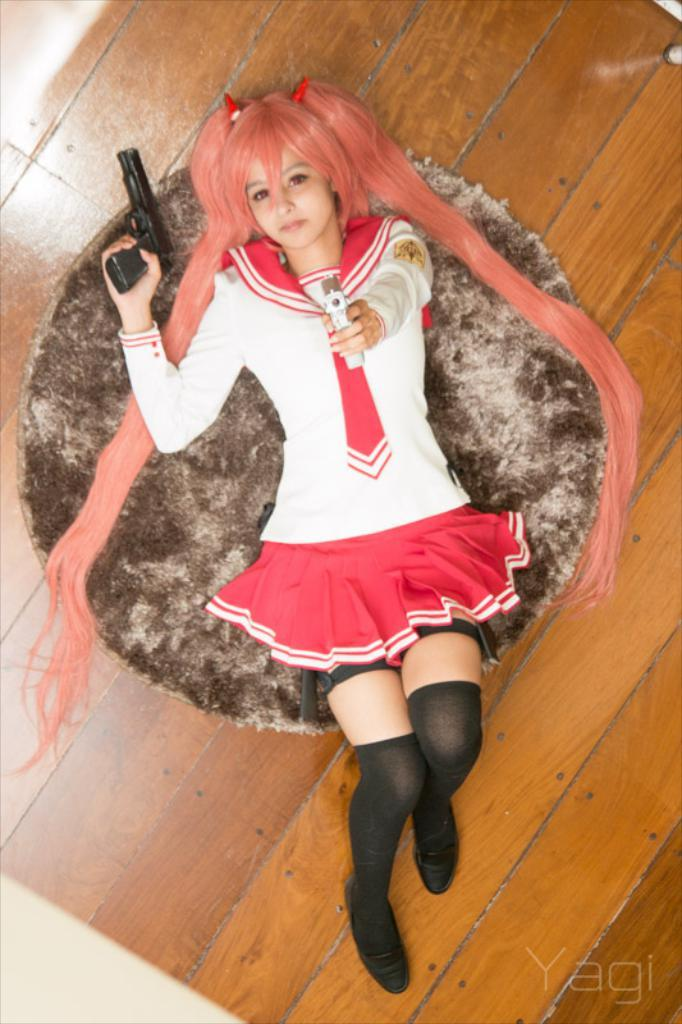What is the main subject of the image? There is a person in the image. What is the person holding in their hands? The person is holding weapons in their hands. Where is the person located in the image? The person is lying on a carpet. What can be seen on the floor in the image? The carpet is visible on the floor. What is present in the bottom right of the image? There is some text in the bottom right of the image. What direction is the shop facing in the image? There is no shop present in the image. What type of doctor is attending to the person in the image? There is no doctor present in the image; the person is holding weapons in their hands. 